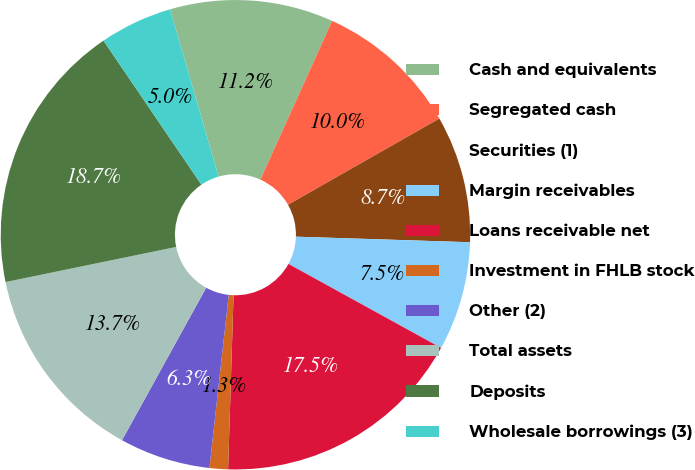Convert chart. <chart><loc_0><loc_0><loc_500><loc_500><pie_chart><fcel>Cash and equivalents<fcel>Segregated cash<fcel>Securities (1)<fcel>Margin receivables<fcel>Loans receivable net<fcel>Investment in FHLB stock<fcel>Other (2)<fcel>Total assets<fcel>Deposits<fcel>Wholesale borrowings (3)<nl><fcel>11.25%<fcel>10.0%<fcel>8.75%<fcel>7.5%<fcel>17.49%<fcel>1.27%<fcel>6.26%<fcel>13.74%<fcel>18.73%<fcel>5.01%<nl></chart> 